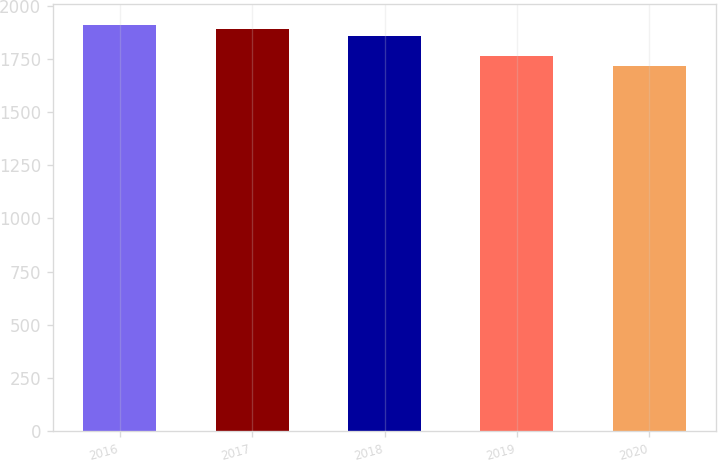Convert chart. <chart><loc_0><loc_0><loc_500><loc_500><bar_chart><fcel>2016<fcel>2017<fcel>2018<fcel>2019<fcel>2020<nl><fcel>1911<fcel>1889<fcel>1858<fcel>1765<fcel>1717<nl></chart> 